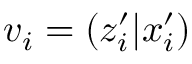Convert formula to latex. <formula><loc_0><loc_0><loc_500><loc_500>v _ { i } = \left ( z _ { i } ^ { \prime } | x _ { i } ^ { \prime } \right )</formula> 